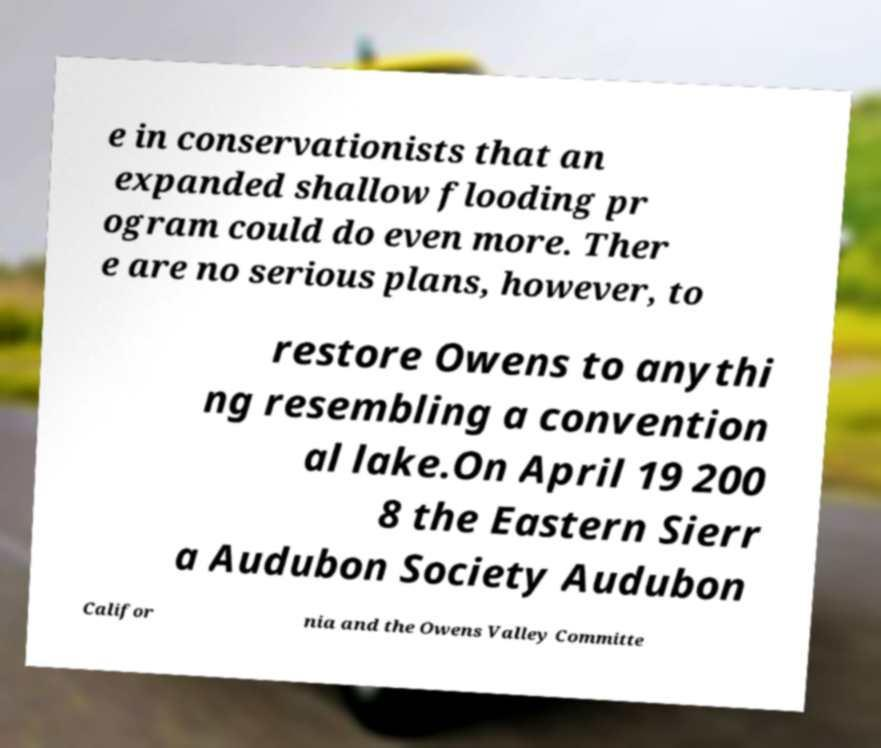I need the written content from this picture converted into text. Can you do that? e in conservationists that an expanded shallow flooding pr ogram could do even more. Ther e are no serious plans, however, to restore Owens to anythi ng resembling a convention al lake.On April 19 200 8 the Eastern Sierr a Audubon Society Audubon Califor nia and the Owens Valley Committe 